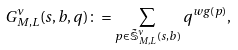<formula> <loc_0><loc_0><loc_500><loc_500>G _ { M , L } ^ { \nu } ( s , b , q ) \colon = \sum _ { p \in \tilde { \mathbb { S } } _ { M , L } ^ { \nu } ( s , b ) } q ^ { w g ( p ) } ,</formula> 